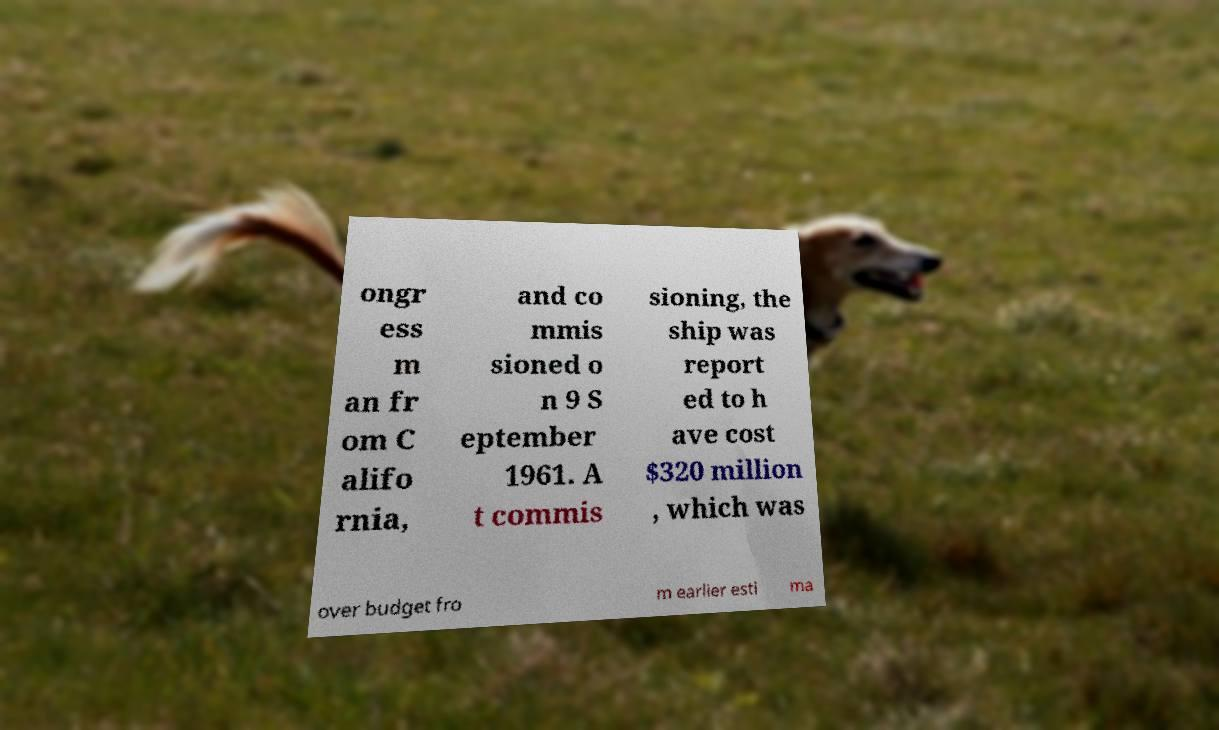Could you assist in decoding the text presented in this image and type it out clearly? ongr ess m an fr om C alifo rnia, and co mmis sioned o n 9 S eptember 1961. A t commis sioning, the ship was report ed to h ave cost $320 million , which was over budget fro m earlier esti ma 